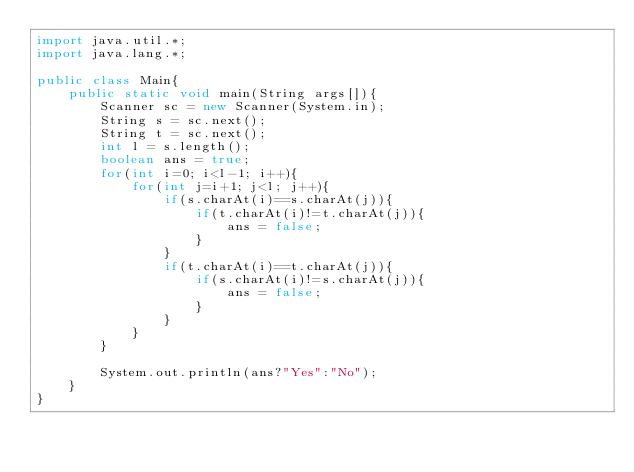Convert code to text. <code><loc_0><loc_0><loc_500><loc_500><_Java_>import java.util.*;
import java.lang.*;

public class Main{
    public static void main(String args[]){
        Scanner sc = new Scanner(System.in);
        String s = sc.next();
        String t = sc.next();
        int l = s.length();
        boolean ans = true;
        for(int i=0; i<l-1; i++){
            for(int j=i+1; j<l; j++){
                if(s.charAt(i)==s.charAt(j)){
                    if(t.charAt(i)!=t.charAt(j)){
                        ans = false;
                    }
                }
                if(t.charAt(i)==t.charAt(j)){
                    if(s.charAt(i)!=s.charAt(j)){
                        ans = false;
                    }
                }                
            }
        }

        System.out.println(ans?"Yes":"No");
    }
}</code> 